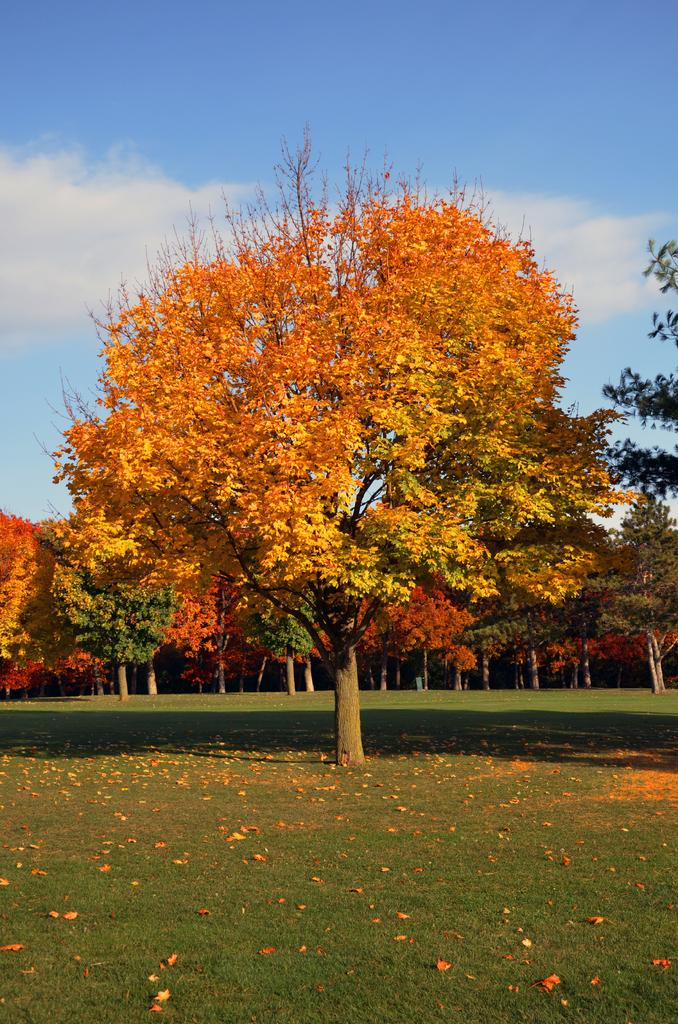What is located in the foreground of the image? There is a tree in the foreground of the image. Can you describe the position of the tree? The tree is on the ground. What can be seen in the background of the image? There are trees, grass, and the sky visible in the background of the image. Is there any weather condition indicated by the sky? Yes, there is a cloud visible in the sky. How many beads are hanging from the tree in the image? There are no beads hanging from the tree in the image. What type of ticket can be seen on the ground near the tree? There is no ticket present in the image. 